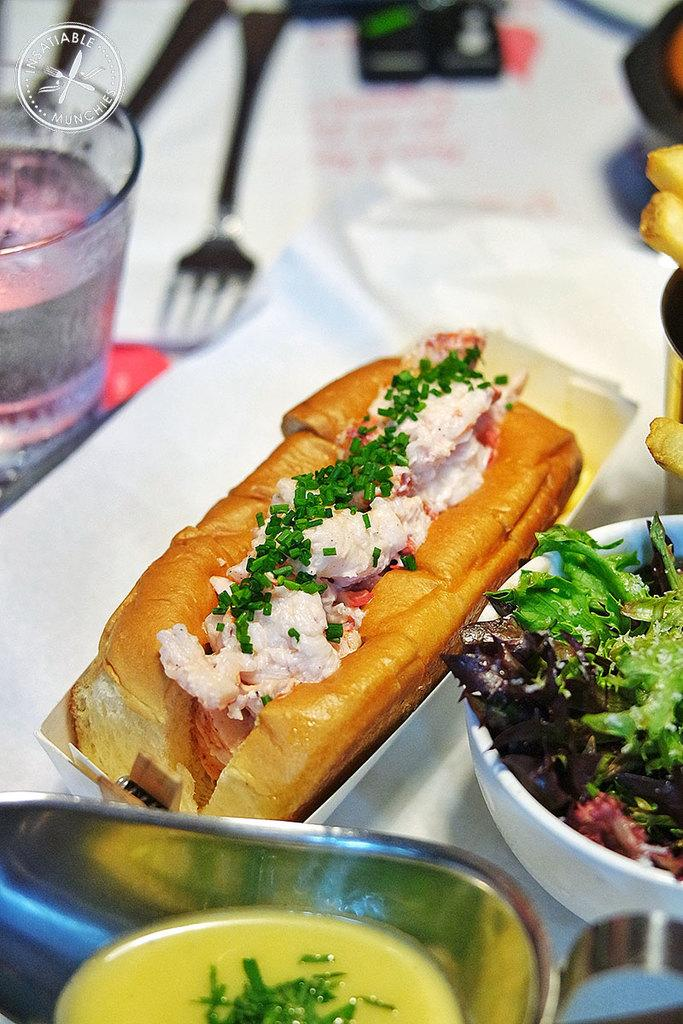What is present in the image? There are food items in the image. Where are the food items placed? The food items are placed on a table. Is there a secretary working at the sink in the image? There is no sink or secretary present in the image. 